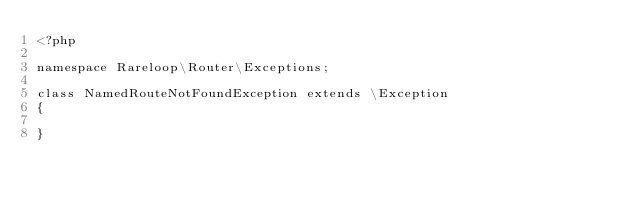Convert code to text. <code><loc_0><loc_0><loc_500><loc_500><_PHP_><?php

namespace Rareloop\Router\Exceptions;

class NamedRouteNotFoundException extends \Exception
{

}
</code> 